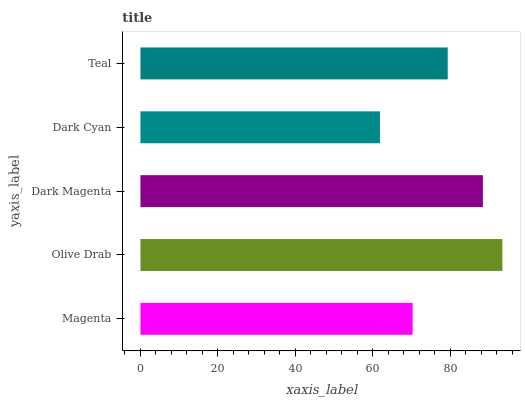Is Dark Cyan the minimum?
Answer yes or no. Yes. Is Olive Drab the maximum?
Answer yes or no. Yes. Is Dark Magenta the minimum?
Answer yes or no. No. Is Dark Magenta the maximum?
Answer yes or no. No. Is Olive Drab greater than Dark Magenta?
Answer yes or no. Yes. Is Dark Magenta less than Olive Drab?
Answer yes or no. Yes. Is Dark Magenta greater than Olive Drab?
Answer yes or no. No. Is Olive Drab less than Dark Magenta?
Answer yes or no. No. Is Teal the high median?
Answer yes or no. Yes. Is Teal the low median?
Answer yes or no. Yes. Is Olive Drab the high median?
Answer yes or no. No. Is Dark Cyan the low median?
Answer yes or no. No. 